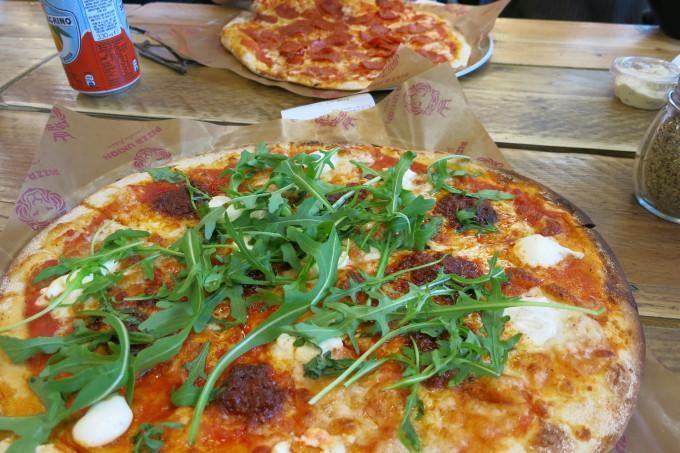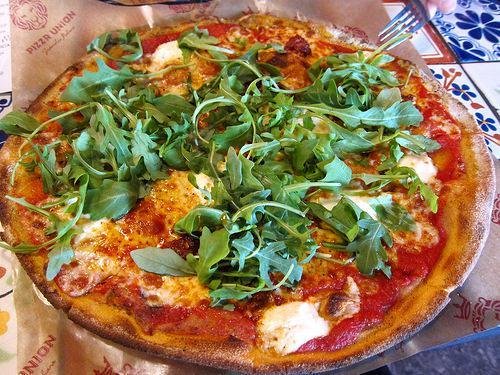The first image is the image on the left, the second image is the image on the right. For the images displayed, is the sentence "There are two pizza and none of them are in a cardboard box." factually correct? Answer yes or no. No. The first image is the image on the left, the second image is the image on the right. For the images displayed, is the sentence "A piece of pizza is missing." factually correct? Answer yes or no. No. 